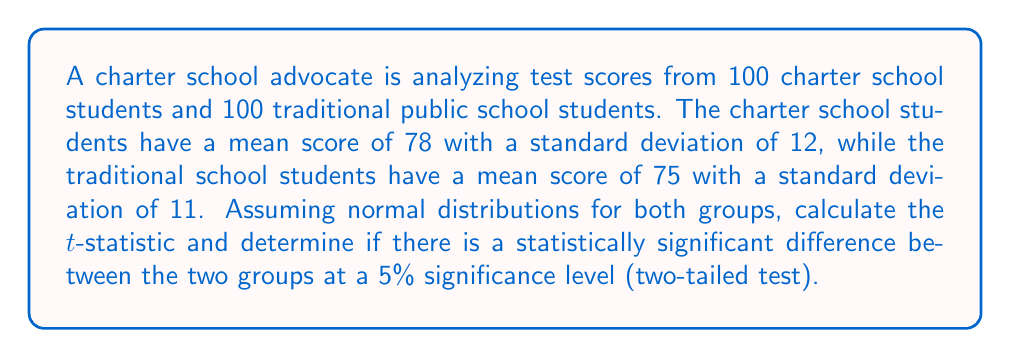Teach me how to tackle this problem. To determine if there is a statistically significant difference between the two groups, we need to perform a two-sample t-test. Here are the steps:

1. Calculate the pooled standard error:
   $$SE = \sqrt{\frac{s_1^2}{n_1} + \frac{s_2^2}{n_2}}$$
   where $s_1$ and $s_2$ are the standard deviations, and $n_1$ and $n_2$ are the sample sizes.

   $$SE = \sqrt{\frac{12^2}{100} + \frac{11^2}{100}} = \sqrt{1.44 + 1.21} = \sqrt{2.65} \approx 1.63$$

2. Calculate the t-statistic:
   $$t = \frac{\bar{x}_1 - \bar{x}_2}{SE}$$
   where $\bar{x}_1$ and $\bar{x}_2$ are the mean scores.

   $$t = \frac{78 - 75}{1.63} \approx 1.84$$

3. Determine the degrees of freedom:
   $$df = n_1 + n_2 - 2 = 100 + 100 - 2 = 198$$

4. Find the critical t-value for a two-tailed test at 5% significance level with 198 degrees of freedom:
   $$t_{critical} \approx \pm 1.972$$ (from t-distribution table)

5. Compare the calculated t-statistic to the critical t-value:
   Since $|1.84| < 1.972$, we fail to reject the null hypothesis.

Therefore, there is not enough evidence to conclude that there is a statistically significant difference between the test scores of charter school students and traditional public school students at the 5% significance level.
Answer: $t \approx 1.84$; Not statistically significant at 5% level 